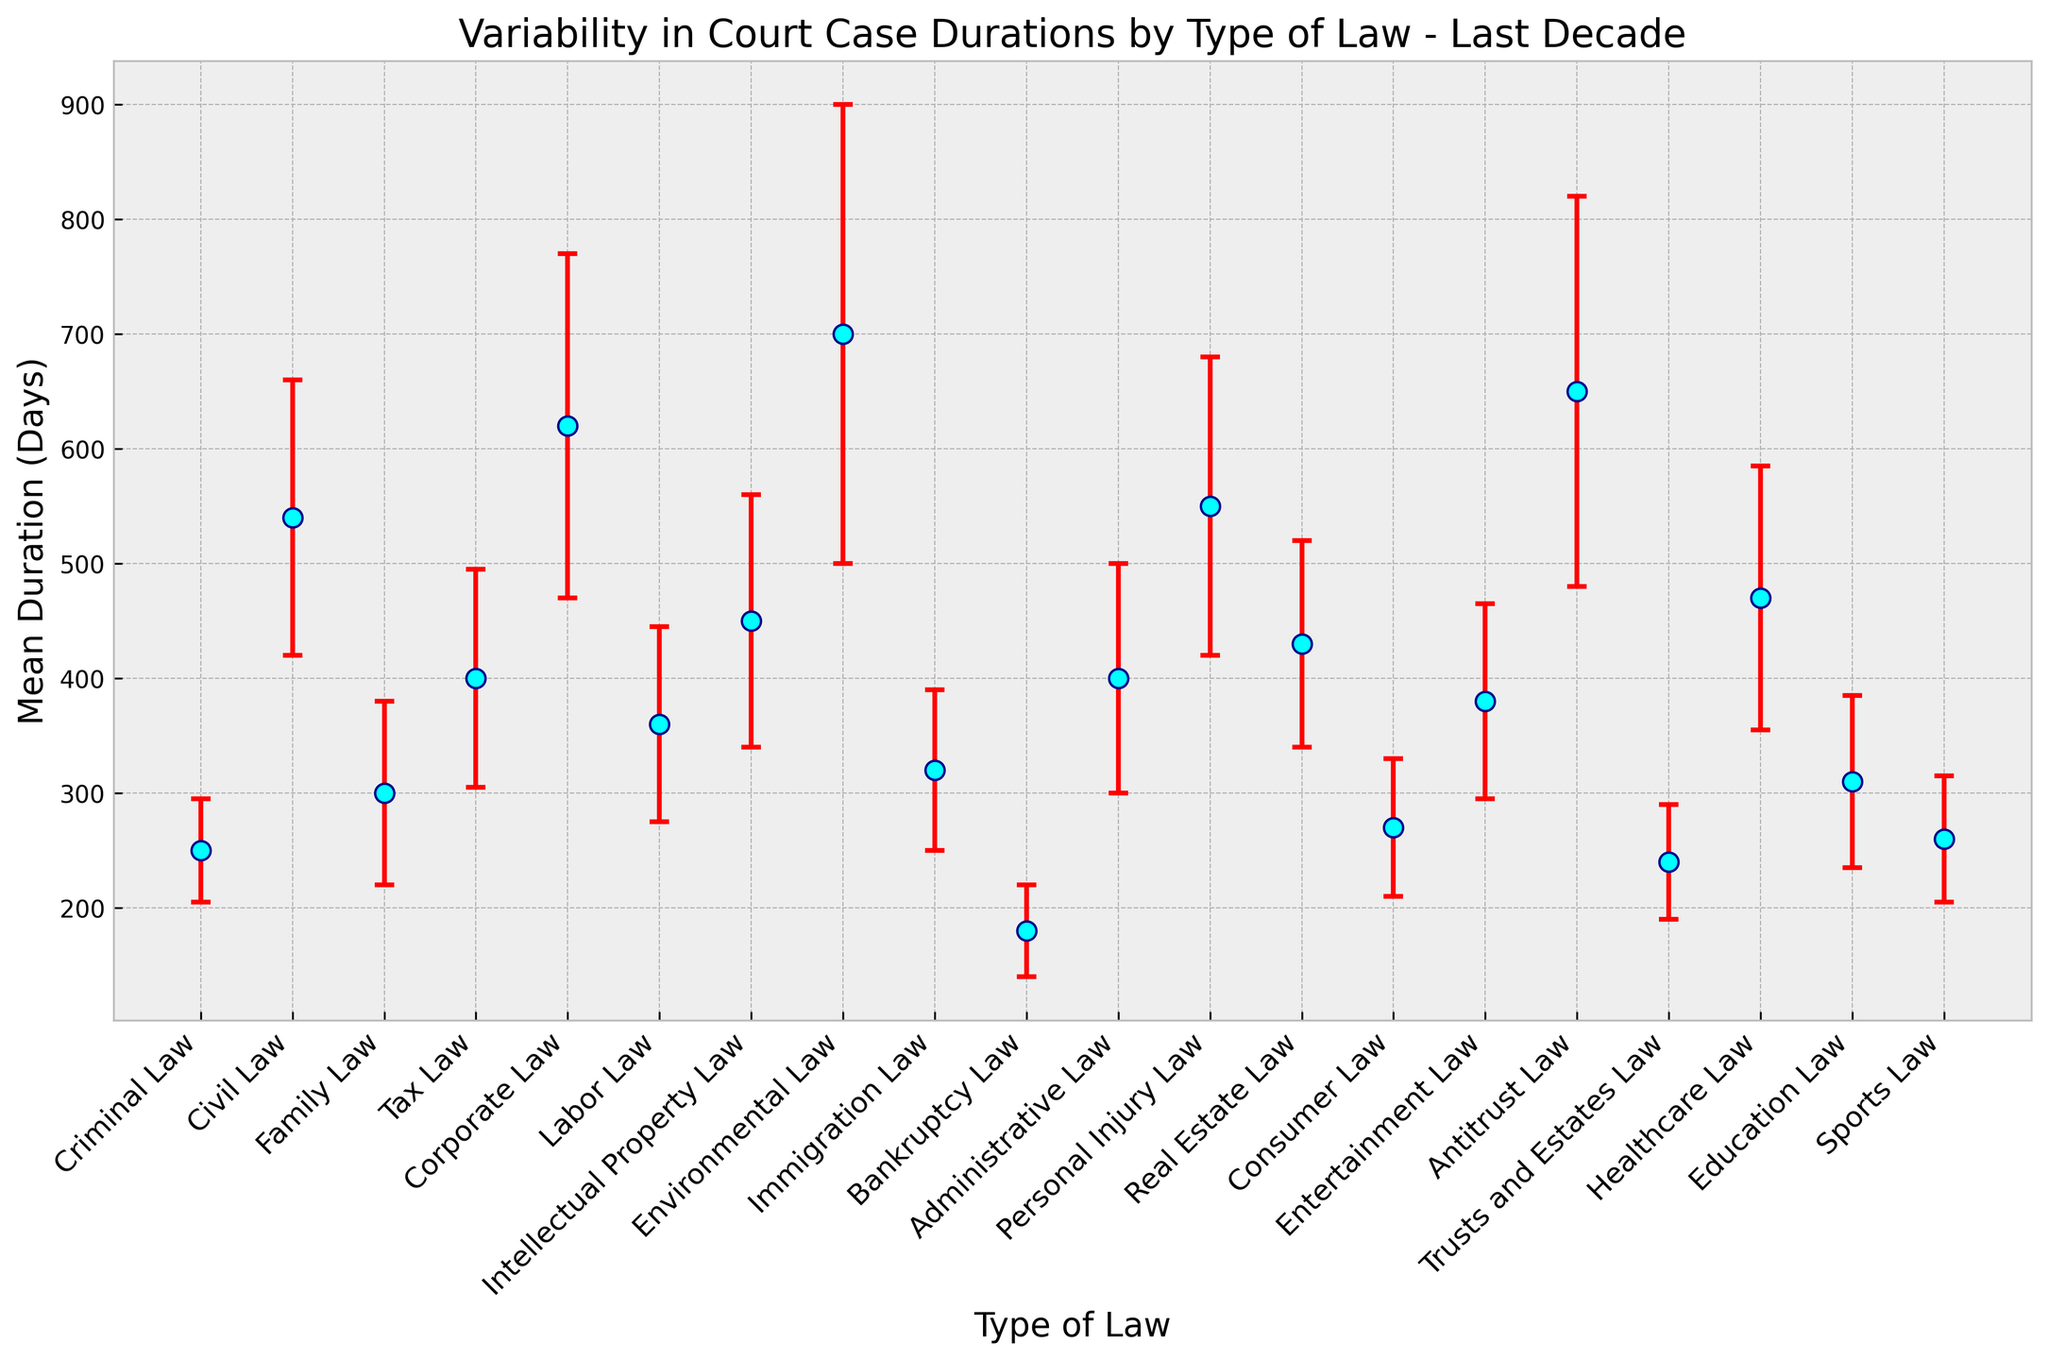What type of law has the longest mean duration for court cases? The longest mean duration can be identified by looking at the error bars and finding the highest point on the plot.
Answer: Environmental Law What is the difference in the mean duration of court cases between Corporate Law and Personal Injury Law? Look at the mean durations for Corporate Law (620 days) and Personal Injury Law (550 days), and subtract the smaller value from the larger value: 620 - 550.
Answer: 70 days Which type of law has the highest variability in court case durations? The highest variability corresponds to the largest error bar.
Answer: Environmental Law How does the mean duration of Family Law compare to Immigration Law? Compare the mean duration values for Family Law (300 days) and Immigration Law (320 days).
Answer: Immigration Law has a slightly longer mean duration Which type of law has a mean duration closest to 400 days? Look at the mean durations and identify the one closest to 400 days.
Answer: Administrative Law By how much does the standard deviation of Healthcare Law exceed that of Family Law? Check the standard deviation values for Healthcare Law (115 days) and Family Law (80 days), and subtract the smaller value from the larger value: 115 - 80.
Answer: 35 days What is the approximate mean duration range for Corporate Law cases considering the standard deviation? Add and subtract the standard deviation (150 days) from the mean duration (620 days) to find the range: [620 - 150, 620 + 150].
Answer: 470 to 770 days Does Bankruptcy Law have higher or lower variability in court case duration compared to Education Law? Compare the standard deviation values for Bankruptcy Law (40 days) and Education Law (75 days).
Answer: Lower Which type of law has a mean duration for court cases under 300 days but with the highest variability within that group? Review the mean durations and standard deviations for types with mean durations under 300 days: Bankruptcy Law and Consumer Law, then compare their standard deviations.
Answer: Consumer Law What two types of law have the closest mean durations? Compare the mean durations of each type of law and find the two that are closest to each other: Family Law (300 days) and Immigration Law (320 days).
Answer: Family Law and Immigration Law 